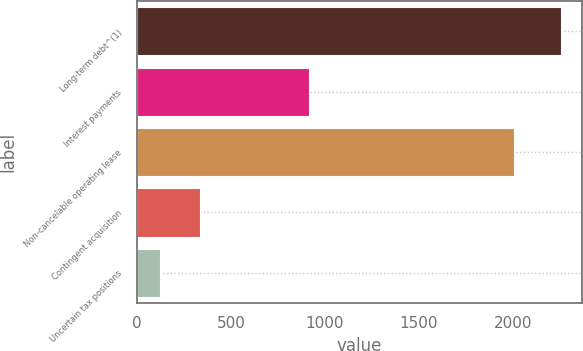Convert chart. <chart><loc_0><loc_0><loc_500><loc_500><bar_chart><fcel>Long-term debt^(1)<fcel>Interest payments<fcel>Non-cancelable operating lease<fcel>Contingent acquisition<fcel>Uncertain tax positions<nl><fcel>2253.3<fcel>914.3<fcel>2006.7<fcel>334.32<fcel>121.1<nl></chart> 